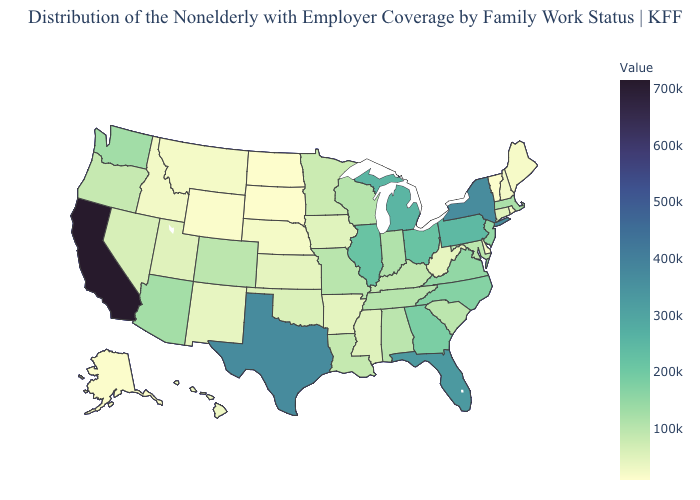Among the states that border California , which have the lowest value?
Short answer required. Nevada. Among the states that border Nevada , which have the lowest value?
Keep it brief. Idaho. Does Kansas have the lowest value in the MidWest?
Give a very brief answer. No. Does Rhode Island have the lowest value in the USA?
Quick response, please. No. Does Montana have the lowest value in the USA?
Write a very short answer. No. Does the map have missing data?
Keep it brief. No. Which states have the lowest value in the MidWest?
Answer briefly. North Dakota. Which states have the lowest value in the USA?
Be succinct. North Dakota. 